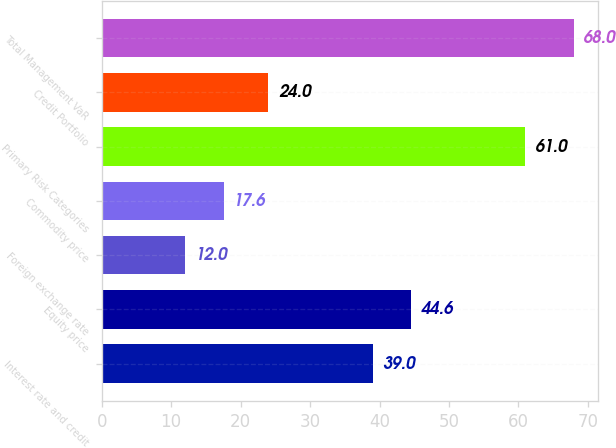<chart> <loc_0><loc_0><loc_500><loc_500><bar_chart><fcel>Interest rate and credit<fcel>Equity price<fcel>Foreign exchange rate<fcel>Commodity price<fcel>Primary Risk Categories<fcel>Credit Portfolio<fcel>Total Management VaR<nl><fcel>39<fcel>44.6<fcel>12<fcel>17.6<fcel>61<fcel>24<fcel>68<nl></chart> 